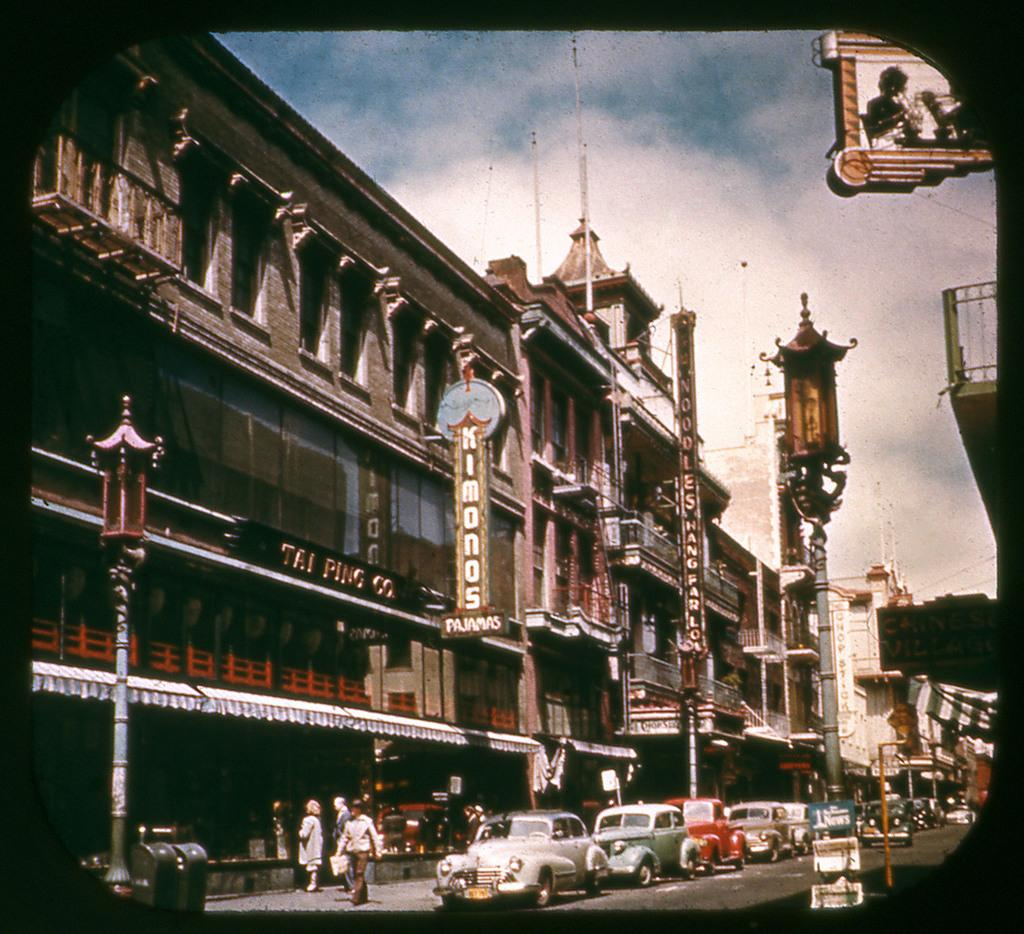<image>
Write a terse but informative summary of the picture. City street with cars and a sign on the building with KIMONOS on it. 